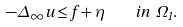Convert formula to latex. <formula><loc_0><loc_0><loc_500><loc_500>- \Delta _ { \infty } u \leq f + \eta \quad i n \ \Omega _ { 1 } .</formula> 